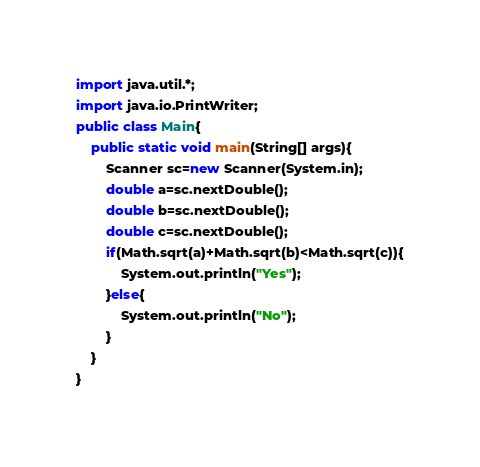<code> <loc_0><loc_0><loc_500><loc_500><_Java_>import java.util.*;
import java.io.PrintWriter;
public class Main{
	public static void main(String[] args){
		Scanner sc=new Scanner(System.in);
		double a=sc.nextDouble();
		double b=sc.nextDouble();
		double c=sc.nextDouble();
		if(Math.sqrt(a)+Math.sqrt(b)<Math.sqrt(c)){
			System.out.println("Yes");
		}else{
			System.out.println("No");
		}
	}
}</code> 